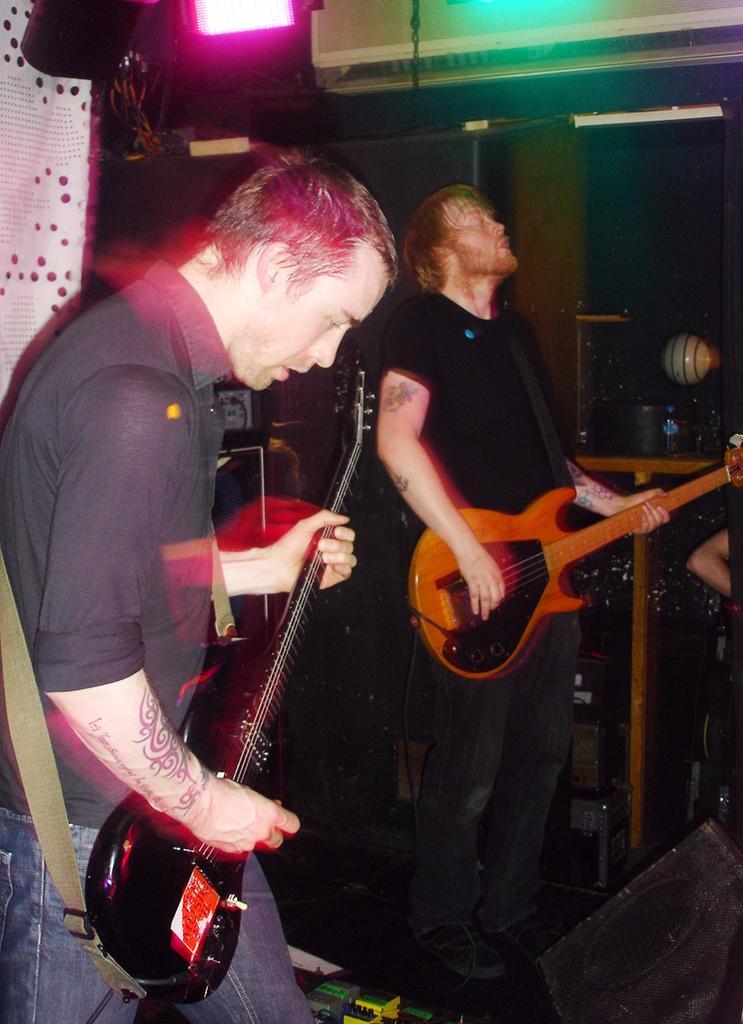Could you give a brief overview of what you see in this image? In this picture we can see two men holding guitars in their hand and playing it and in background we can see cloth, light 